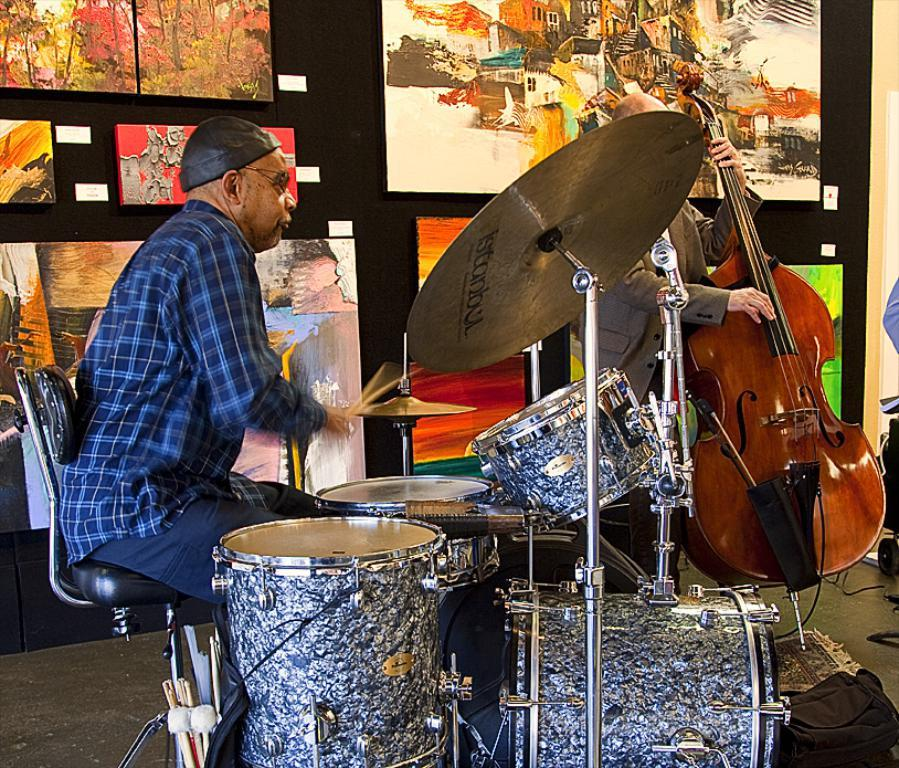What type of structure can be seen in the image? There is a wall in the image. What decorative items are present on the wall? There are photo frames in the image. What musical instruments can be seen in the image? There are musical drums in the image. How many people are in the image? There are two people in the image. What type of furniture is present in the image? There is a chair in the image. Where is the man holding a guitar located in the image? The man holding a guitar is on the right side of the image. How many rabbits are hopping around in the image? There are no rabbits present in the image. What type of frog can be seen sitting on the chair in the image? There is no frog present in the image; only a chair is visible. 